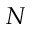Convert formula to latex. <formula><loc_0><loc_0><loc_500><loc_500>N</formula> 